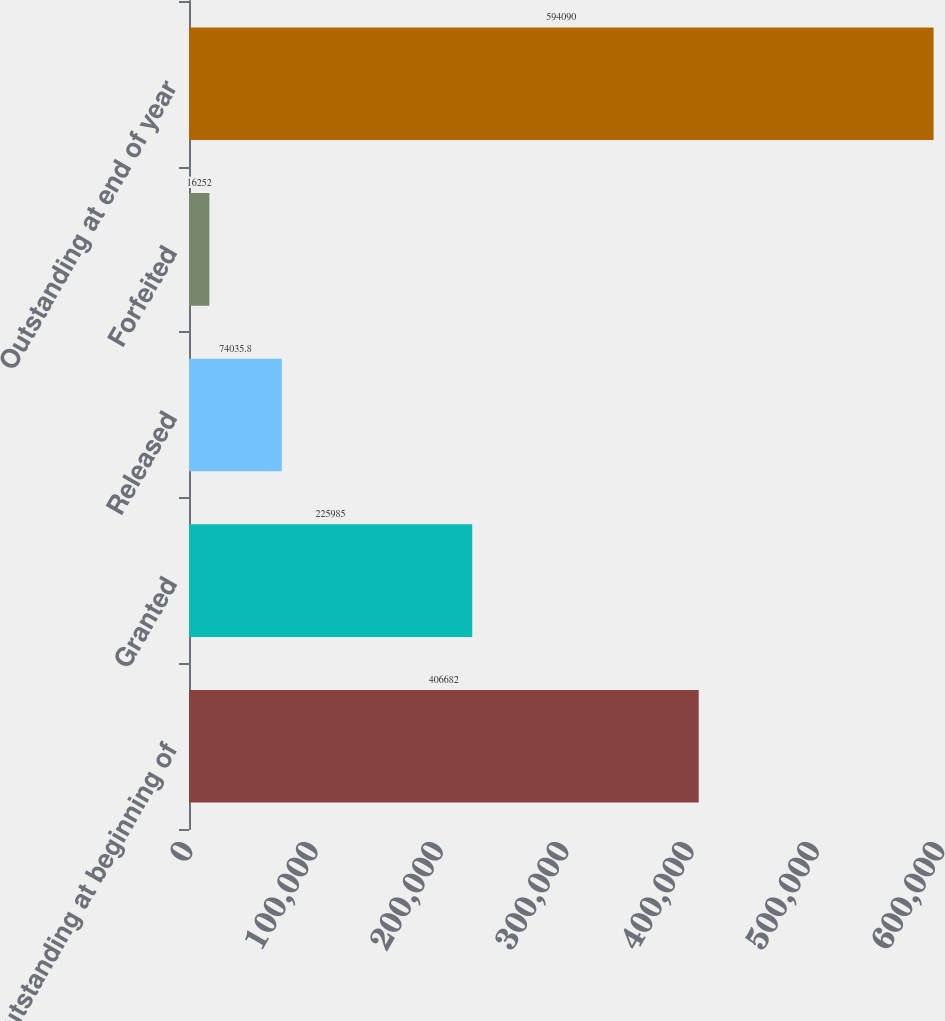Convert chart to OTSL. <chart><loc_0><loc_0><loc_500><loc_500><bar_chart><fcel>Outstanding at beginning of<fcel>Granted<fcel>Released<fcel>Forfeited<fcel>Outstanding at end of year<nl><fcel>406682<fcel>225985<fcel>74035.8<fcel>16252<fcel>594090<nl></chart> 